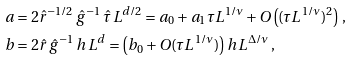<formula> <loc_0><loc_0><loc_500><loc_500>a & = 2 \hat { r } ^ { - 1 / 2 } \, \hat { g } ^ { - 1 } \, \hat { \tau } \, L ^ { d / 2 } = a _ { 0 } + a _ { 1 } \tau L ^ { 1 / \nu } + O \left ( ( \tau L ^ { 1 / \nu } ) ^ { 2 } \right ) \, , \\ b & = 2 \hat { r } \, \hat { g } ^ { - 1 } \, h \, L ^ { d } = \left ( b _ { 0 } + O ( \tau L ^ { 1 / \nu } ) \right ) h \, L ^ { \Delta / \nu } \, ,</formula> 